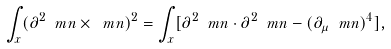Convert formula to latex. <formula><loc_0><loc_0><loc_500><loc_500>\int _ { x } ( \partial ^ { 2 } \ m n \times \ m n ) ^ { 2 } = \int _ { x } [ \partial ^ { 2 } \ m n \cdot \partial ^ { 2 } \ m n - ( \partial _ { \mu } \ m n ) ^ { 4 } ] ,</formula> 